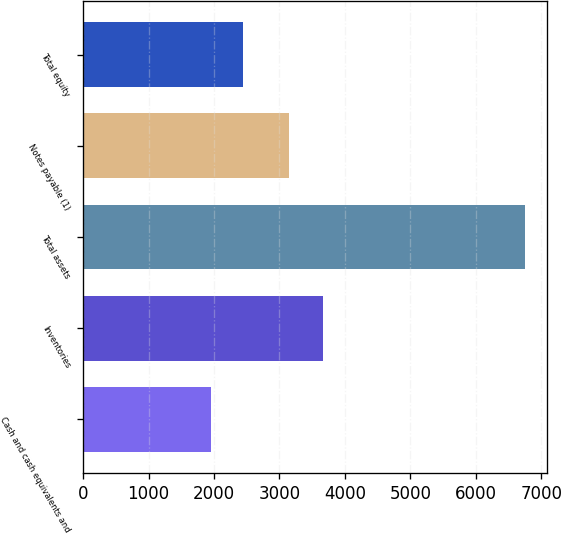Convert chart to OTSL. <chart><loc_0><loc_0><loc_500><loc_500><bar_chart><fcel>Cash and cash equivalents and<fcel>Inventories<fcel>Total assets<fcel>Notes payable (1)<fcel>Total equity<nl><fcel>1957.3<fcel>3666.7<fcel>6756.8<fcel>3145.3<fcel>2437.25<nl></chart> 